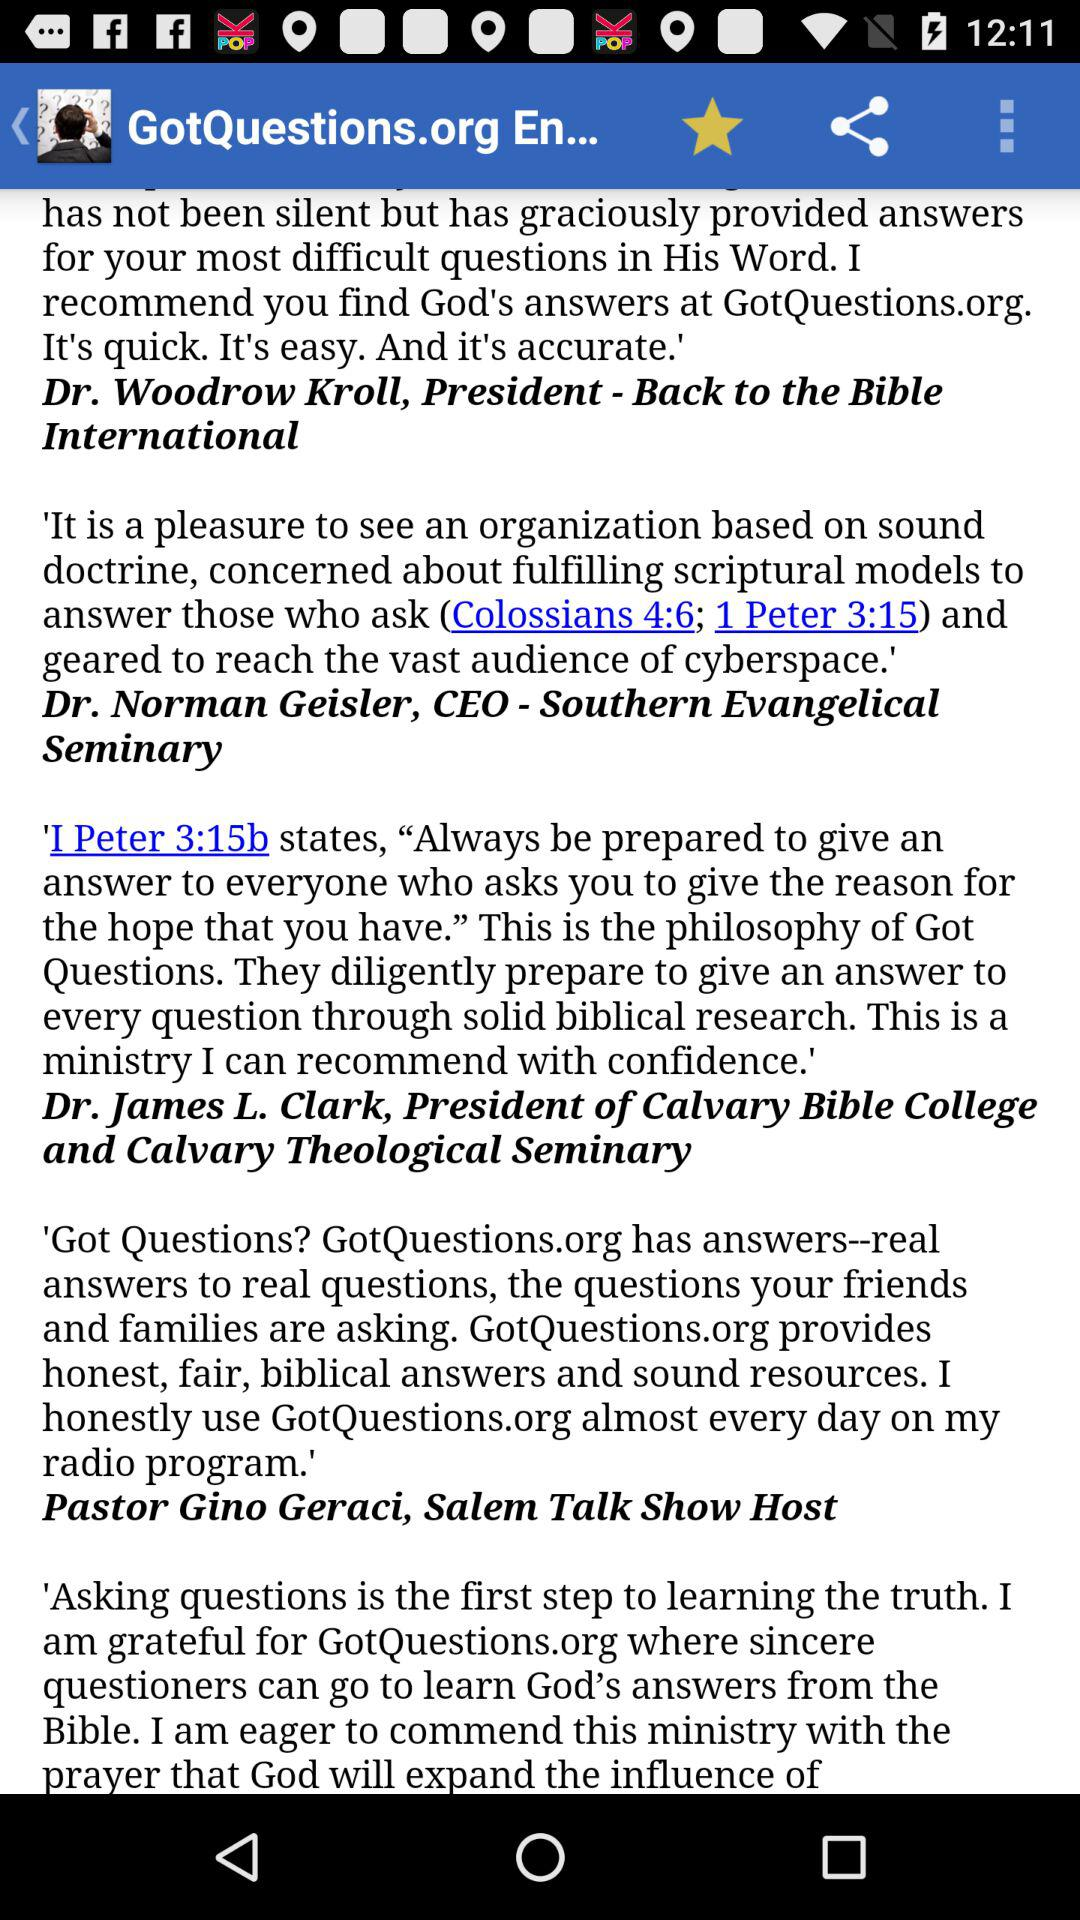Who is the President of "Calvary Bible College and Calvary Theological Seminary"? The President is Dr. James L. Clark. 